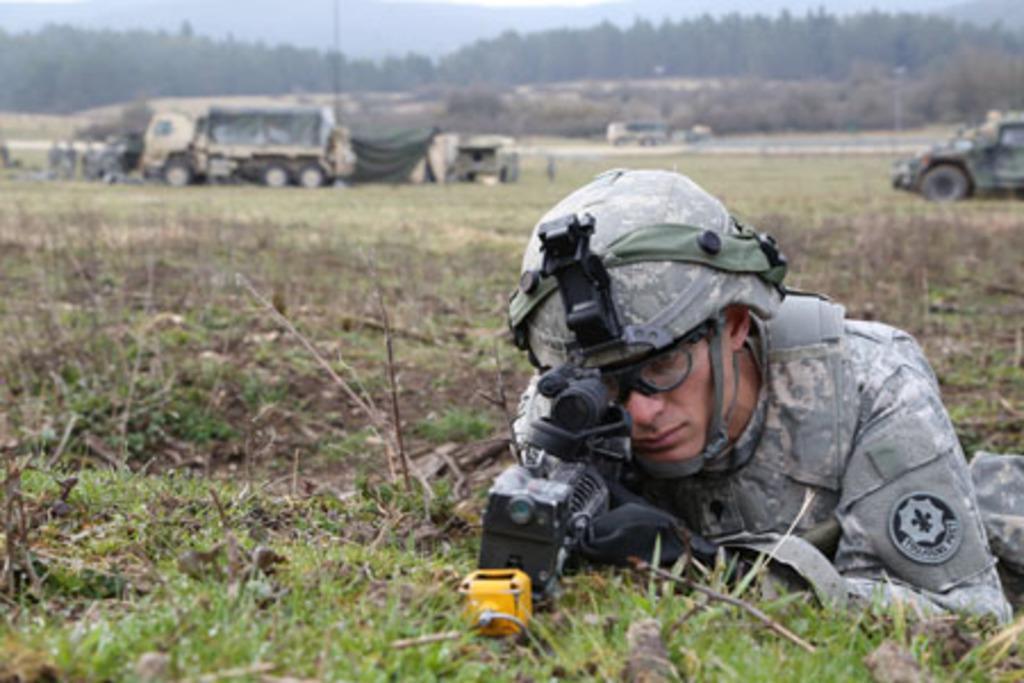Can you describe this image briefly? In this image we can see a man wearing the military uniform and holding the gun. We can also see the vehicles and trees and also the sky in the background and at the bottom we can see the grass. 